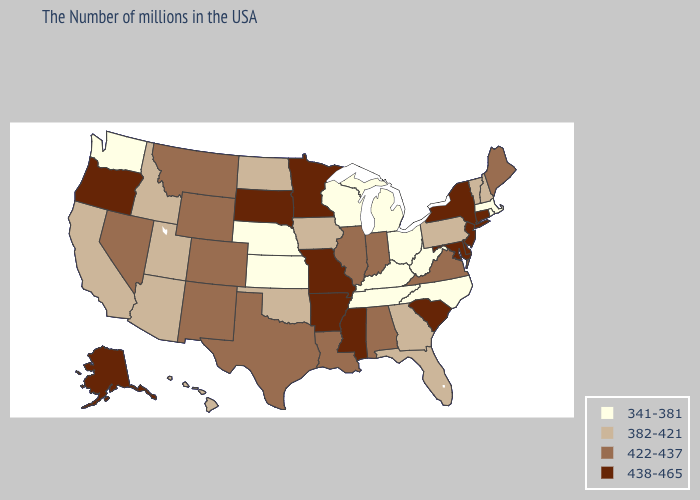Name the states that have a value in the range 382-421?
Write a very short answer. New Hampshire, Vermont, Pennsylvania, Florida, Georgia, Iowa, Oklahoma, North Dakota, Utah, Arizona, Idaho, California, Hawaii. Name the states that have a value in the range 382-421?
Keep it brief. New Hampshire, Vermont, Pennsylvania, Florida, Georgia, Iowa, Oklahoma, North Dakota, Utah, Arizona, Idaho, California, Hawaii. Which states have the lowest value in the South?
Concise answer only. North Carolina, West Virginia, Kentucky, Tennessee. What is the value of North Dakota?
Write a very short answer. 382-421. What is the highest value in the West ?
Answer briefly. 438-465. Name the states that have a value in the range 341-381?
Concise answer only. Massachusetts, Rhode Island, North Carolina, West Virginia, Ohio, Michigan, Kentucky, Tennessee, Wisconsin, Kansas, Nebraska, Washington. Among the states that border West Virginia , which have the lowest value?
Give a very brief answer. Ohio, Kentucky. Does South Carolina have the highest value in the South?
Short answer required. Yes. Name the states that have a value in the range 422-437?
Keep it brief. Maine, Virginia, Indiana, Alabama, Illinois, Louisiana, Texas, Wyoming, Colorado, New Mexico, Montana, Nevada. Does Arizona have a lower value than Utah?
Give a very brief answer. No. Name the states that have a value in the range 422-437?
Answer briefly. Maine, Virginia, Indiana, Alabama, Illinois, Louisiana, Texas, Wyoming, Colorado, New Mexico, Montana, Nevada. Does the first symbol in the legend represent the smallest category?
Quick response, please. Yes. Name the states that have a value in the range 382-421?
Concise answer only. New Hampshire, Vermont, Pennsylvania, Florida, Georgia, Iowa, Oklahoma, North Dakota, Utah, Arizona, Idaho, California, Hawaii. What is the highest value in the South ?
Quick response, please. 438-465. Does New Jersey have the lowest value in the Northeast?
Be succinct. No. 